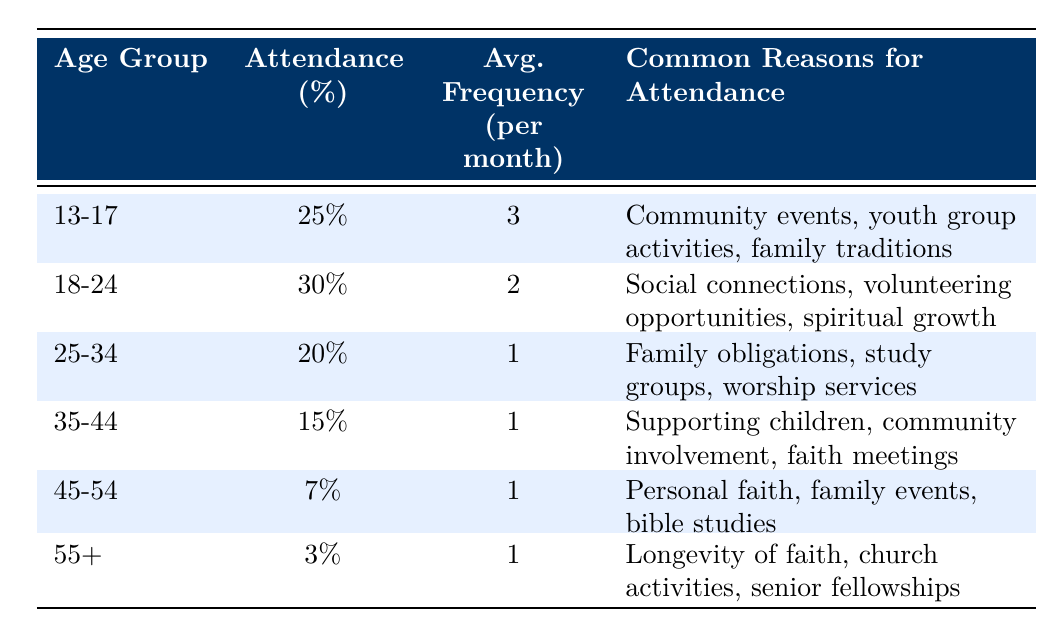What is the attendance percentage for the age group 18-24? According to the table, the attendance percentage for the age group 18-24 is listed directly under that category.
Answer: 30% Which age group has the highest average attendance frequency per month? The age group 13-17 has an average attendance frequency of 3 per month, which is higher than any other age group listed.
Answer: 13-17 How many age groups have an attendance percentage of 20% or lower? The age groups with attendance percentages of 20% or lower are 25-34 (20%), 35-44 (15%), 45-54 (7%), and 55+ (3%). There are four of these age groups altogether.
Answer: 4 What is the average attendance percentage of the groups that attend church more than once a month? The only groups that attend church more than once a month are 13-17 (25%) and 18-24 (30%). Adding these together, 25 + 30 = 55, and dividing by 2 gives us an average of 27.5%.
Answer: 27.5% Is it true that the 55+ age group attends church more frequently than the 45-54 age group? No, both age groups have an average attendance frequency of 1 per month, so they attend church at the same frequency.
Answer: No Which age group reports "social connections" as a common reason for attendance? The common reasons for attendance for the 18-24 age group include "social connections" as one of its primary motivators.
Answer: 18-24 What is the total attendance percentage of the age groups that attend church once a month? The age groups that attend church once a month are 25-34, 35-44, 45-54, and 55+, which have percentages of 20%, 15%, 7%, and 3%, respectively. Adding these together gives us 20 + 15 + 7 + 3 = 45%.
Answer: 45% Do the majority of attendees in the age group 13-17 have common reasons for attending that involve community events? Yes, the common reasons listed for the 13-17 age group include "community events," so it can be concluded that community events are a major factor for this age group.
Answer: Yes What age group has the lowest attendance percentage? The age group 55+ has the lowest attendance percentage, which is 3%.
Answer: 55+ 